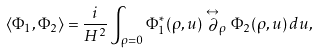<formula> <loc_0><loc_0><loc_500><loc_500>\langle \Phi _ { 1 } , \Phi _ { 2 } \rangle = \frac { i } { H ^ { 2 } } \int _ { \rho = 0 } \Phi _ { 1 } ^ { * } ( \rho , u ) \stackrel { \leftrightarrow } { \partial } _ { \rho } \Phi _ { 2 } ( \rho , u ) \, d u ,</formula> 